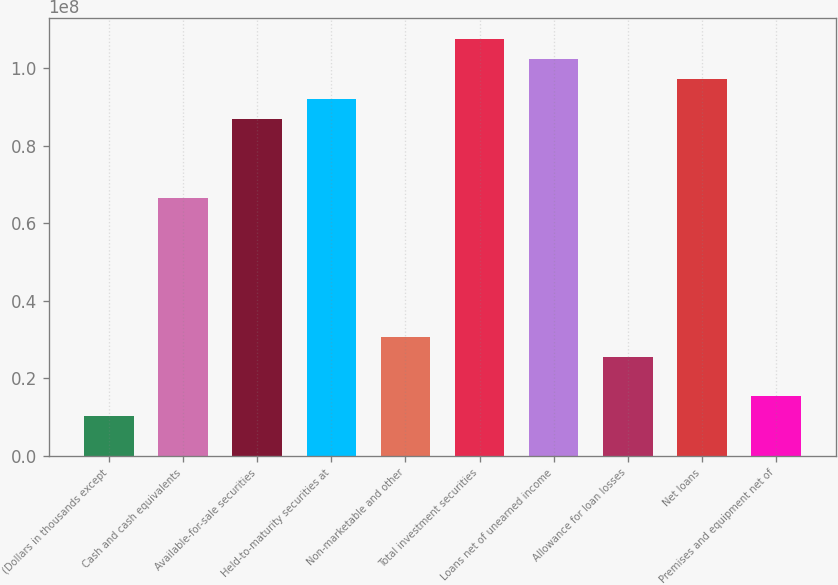Convert chart. <chart><loc_0><loc_0><loc_500><loc_500><bar_chart><fcel>(Dollars in thousands except<fcel>Cash and cash equivalents<fcel>Available-for-sale securities<fcel>Held-to-maturity securities at<fcel>Non-marketable and other<fcel>Total investment securities<fcel>Loans net of unearned income<fcel>Allowance for loan losses<fcel>Net loans<fcel>Premises and equipment net of<nl><fcel>1.02429e+07<fcel>6.65788e+07<fcel>8.70646e+07<fcel>9.2186e+07<fcel>3.07287e+07<fcel>1.0755e+08<fcel>1.02429e+08<fcel>2.56073e+07<fcel>9.73074e+07<fcel>1.53644e+07<nl></chart> 